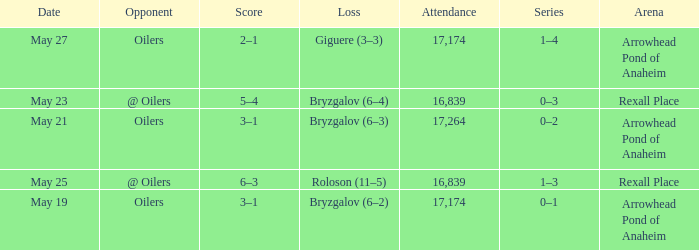Which Arena has an Opponent of @ oilers, and a Date of may 25? Rexall Place. 